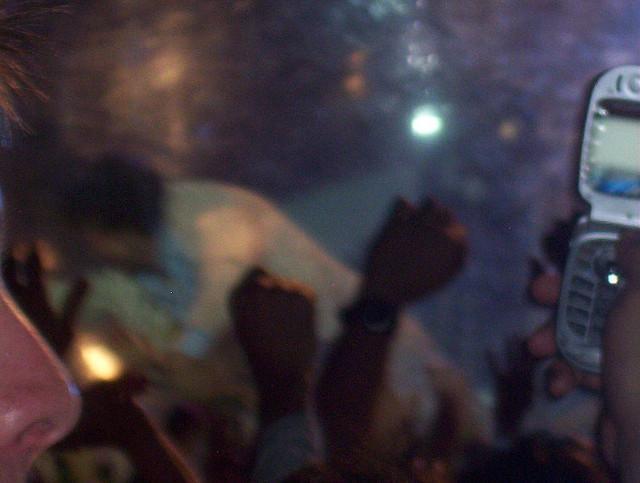How many people are there?
Give a very brief answer. 6. How many of the dogs feet are touching the ground?
Give a very brief answer. 0. 